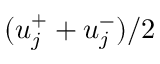<formula> <loc_0><loc_0><loc_500><loc_500>( u _ { j } ^ { + } + u _ { j } ^ { - } ) / 2</formula> 